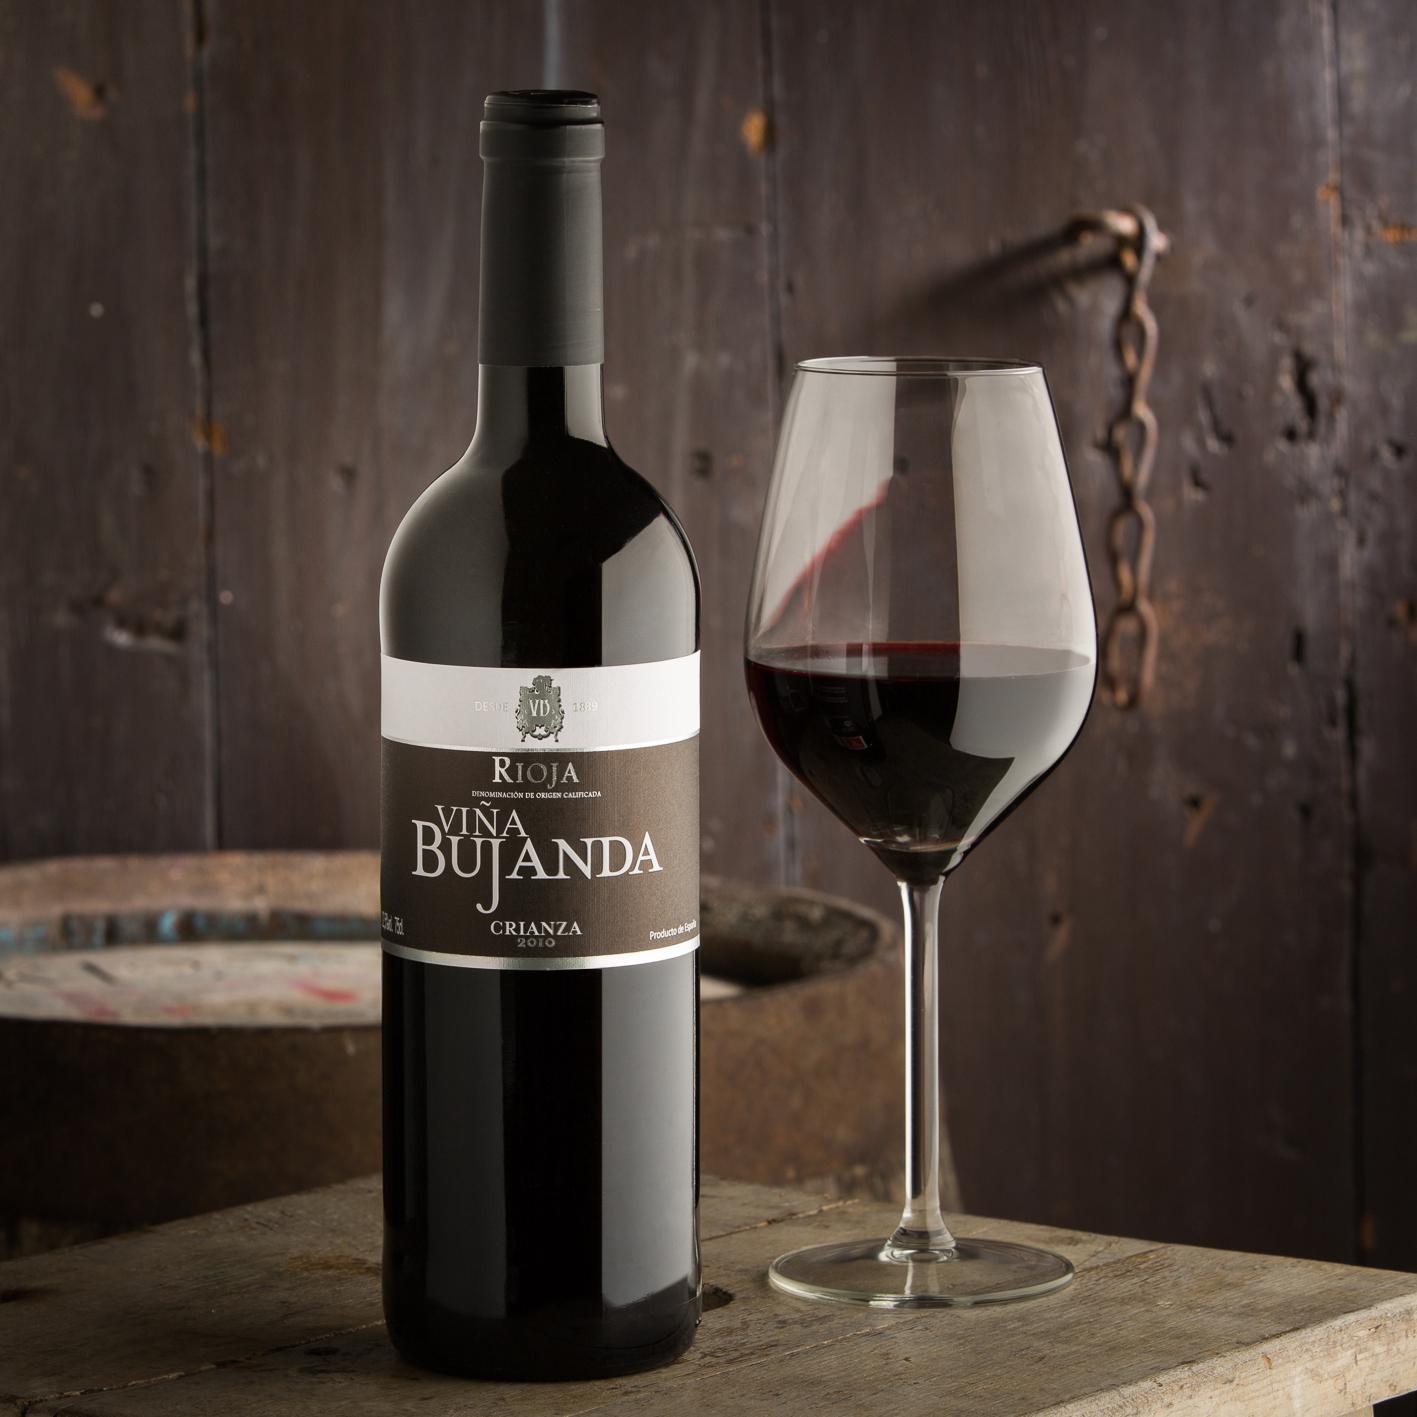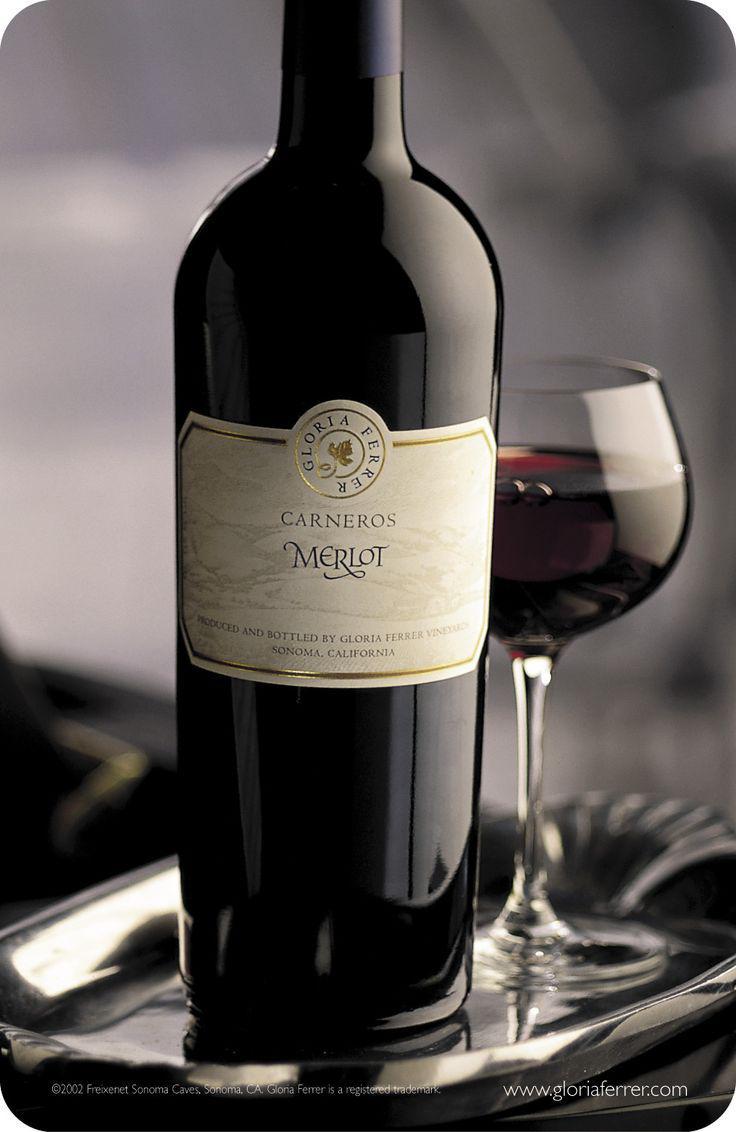The first image is the image on the left, the second image is the image on the right. Analyze the images presented: Is the assertion "In one of the images, there are two glasses of red wine side by side" valid? Answer yes or no. No. The first image is the image on the left, the second image is the image on the right. For the images displayed, is the sentence "There are at least six wine bottles in one of the images." factually correct? Answer yes or no. No. 